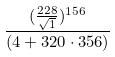Convert formula to latex. <formula><loc_0><loc_0><loc_500><loc_500>\frac { ( \frac { 2 2 8 } { \sqrt { 1 } } ) ^ { 1 5 6 } } { ( 4 + 3 2 0 \cdot 3 5 6 ) }</formula> 